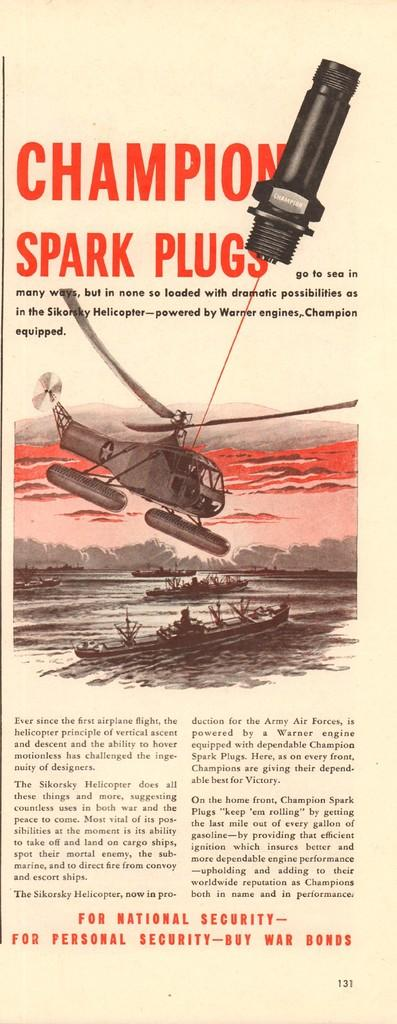What is the main subject of the image? The main subject of the image is an aircraft. Can you describe the color of the aircraft? The aircraft is gray in color. What other mode of transportation can be seen in the image? There is a boat on the water in the image. What colors are used for the text in the image? The text in the image is written using black and red colors. What is the rate of the alarm going off in the image? There is no alarm present in the image, so it is not possible to determine a rate. 